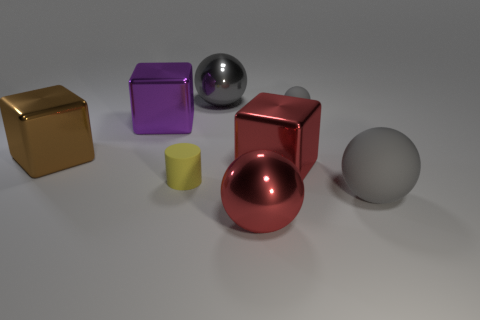What is the material of the brown object that is the same shape as the purple metal thing?
Make the answer very short. Metal. There is a large ball behind the large purple cube that is behind the yellow matte thing that is in front of the small gray matte sphere; what is its color?
Provide a short and direct response. Gray. Does the large red object in front of the tiny yellow rubber thing have the same material as the tiny ball?
Your response must be concise. No. How many other things are there of the same material as the red sphere?
Keep it short and to the point. 4. There is a red cube that is the same size as the purple thing; what is it made of?
Offer a very short reply. Metal. There is a gray object that is in front of the brown cube; does it have the same shape as the small matte object to the right of the red metallic ball?
Your answer should be very brief. Yes. What is the shape of the gray matte object that is the same size as the yellow rubber cylinder?
Provide a short and direct response. Sphere. Does the thing left of the purple shiny thing have the same material as the tiny object in front of the purple cube?
Offer a very short reply. No. Is there a sphere right of the big object that is behind the purple metallic object?
Offer a terse response. Yes. There is a small sphere that is made of the same material as the yellow cylinder; what color is it?
Keep it short and to the point. Gray. 